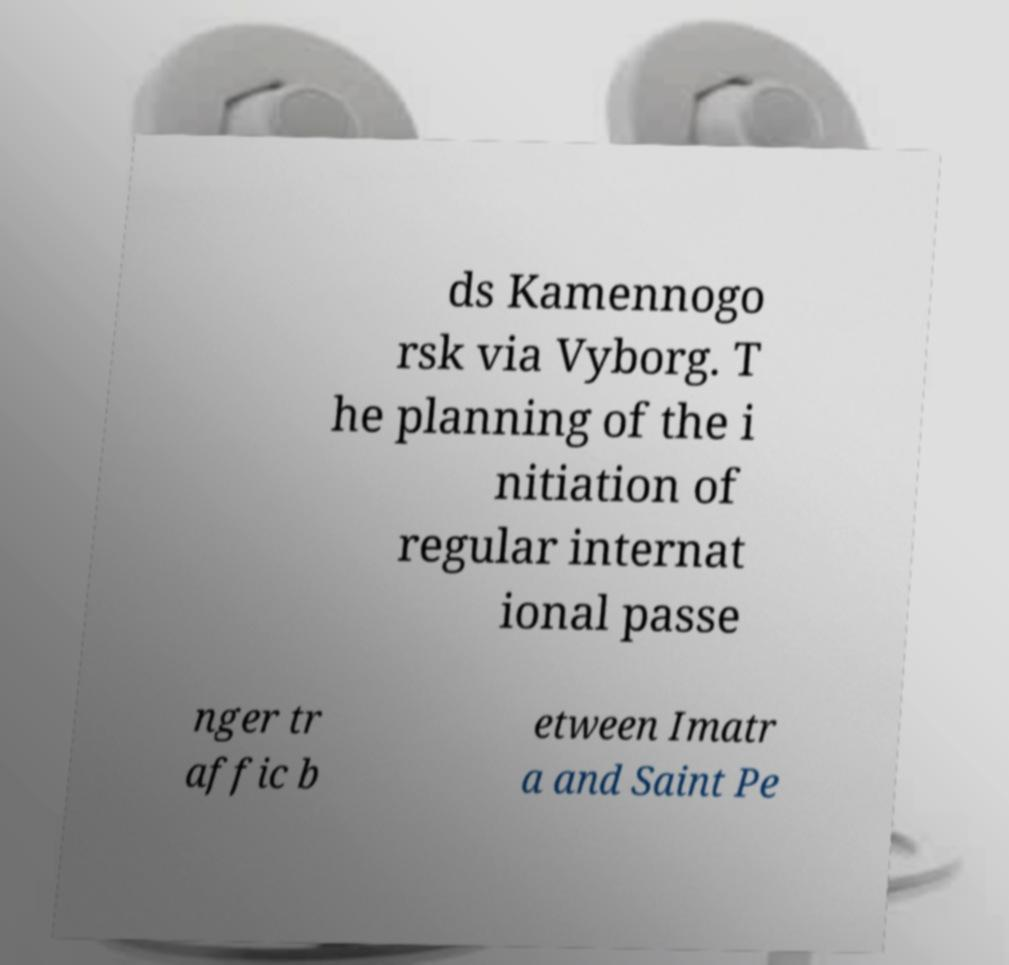What messages or text are displayed in this image? I need them in a readable, typed format. ds Kamennogo rsk via Vyborg. T he planning of the i nitiation of regular internat ional passe nger tr affic b etween Imatr a and Saint Pe 